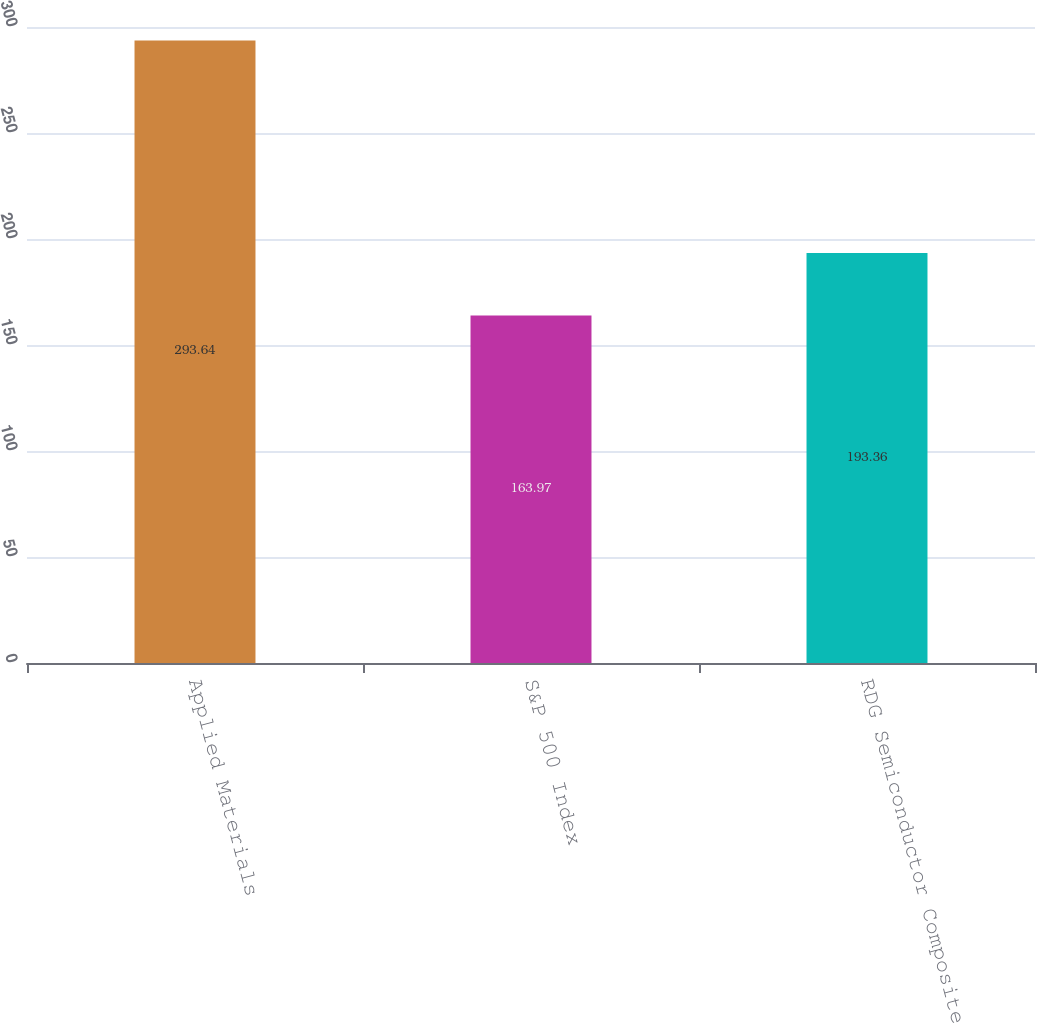Convert chart. <chart><loc_0><loc_0><loc_500><loc_500><bar_chart><fcel>Applied Materials<fcel>S&P 500 Index<fcel>RDG Semiconductor Composite<nl><fcel>293.64<fcel>163.97<fcel>193.36<nl></chart> 